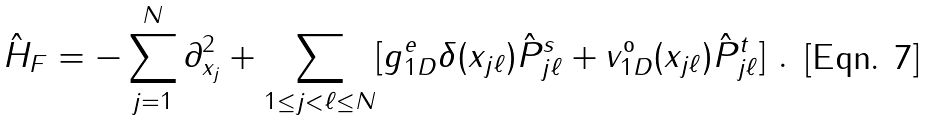Convert formula to latex. <formula><loc_0><loc_0><loc_500><loc_500>\hat { H } _ { F } = - \sum _ { j = 1 } ^ { N } \partial _ { x _ { j } } ^ { 2 } + \sum _ { 1 \leq j < \ell \leq N } [ g _ { 1 D } ^ { e } \delta ( x _ { j \ell } ) \hat { P } _ { j \ell } ^ { s } + v _ { 1 D } ^ { \text {o} } ( x _ { j \ell } ) \hat { P } _ { j \ell } ^ { t } ] \ .</formula> 